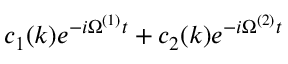Convert formula to latex. <formula><loc_0><loc_0><loc_500><loc_500>c _ { 1 } ( k ) e ^ { - i \Omega ^ { ( 1 ) } t } + c _ { 2 } ( k ) e ^ { - i \Omega ^ { ( 2 ) } t }</formula> 